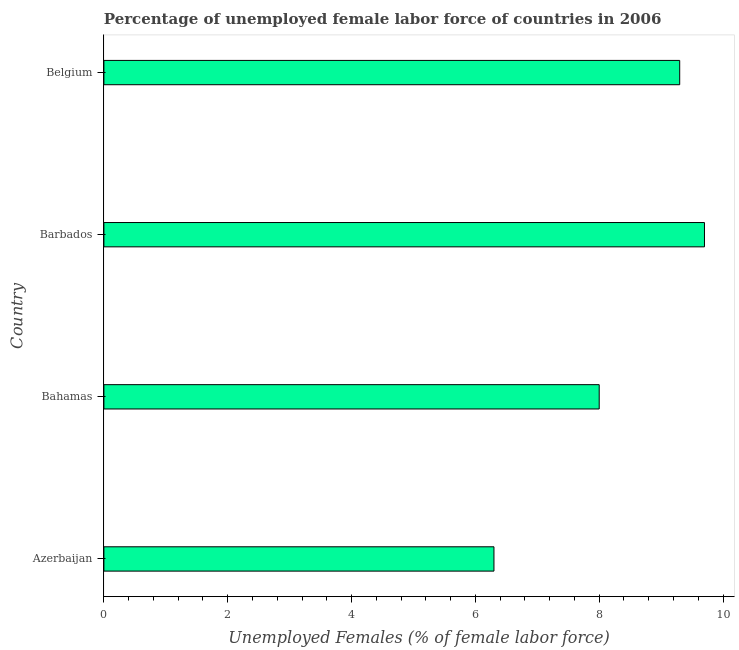Does the graph contain any zero values?
Your answer should be very brief. No. What is the title of the graph?
Keep it short and to the point. Percentage of unemployed female labor force of countries in 2006. What is the label or title of the X-axis?
Keep it short and to the point. Unemployed Females (% of female labor force). What is the label or title of the Y-axis?
Make the answer very short. Country. Across all countries, what is the maximum total unemployed female labour force?
Give a very brief answer. 9.7. Across all countries, what is the minimum total unemployed female labour force?
Make the answer very short. 6.3. In which country was the total unemployed female labour force maximum?
Your answer should be compact. Barbados. In which country was the total unemployed female labour force minimum?
Offer a terse response. Azerbaijan. What is the sum of the total unemployed female labour force?
Keep it short and to the point. 33.3. What is the difference between the total unemployed female labour force in Bahamas and Barbados?
Make the answer very short. -1.7. What is the average total unemployed female labour force per country?
Give a very brief answer. 8.32. What is the median total unemployed female labour force?
Give a very brief answer. 8.65. What is the ratio of the total unemployed female labour force in Azerbaijan to that in Bahamas?
Offer a very short reply. 0.79. What is the difference between the highest and the second highest total unemployed female labour force?
Make the answer very short. 0.4. Is the sum of the total unemployed female labour force in Azerbaijan and Barbados greater than the maximum total unemployed female labour force across all countries?
Provide a succinct answer. Yes. Are all the bars in the graph horizontal?
Provide a short and direct response. Yes. What is the Unemployed Females (% of female labor force) in Azerbaijan?
Give a very brief answer. 6.3. What is the Unemployed Females (% of female labor force) of Barbados?
Provide a succinct answer. 9.7. What is the Unemployed Females (% of female labor force) of Belgium?
Your response must be concise. 9.3. What is the difference between the Unemployed Females (% of female labor force) in Azerbaijan and Bahamas?
Give a very brief answer. -1.7. What is the difference between the Unemployed Females (% of female labor force) in Azerbaijan and Barbados?
Your answer should be very brief. -3.4. What is the difference between the Unemployed Females (% of female labor force) in Azerbaijan and Belgium?
Your response must be concise. -3. What is the difference between the Unemployed Females (% of female labor force) in Barbados and Belgium?
Your response must be concise. 0.4. What is the ratio of the Unemployed Females (% of female labor force) in Azerbaijan to that in Bahamas?
Offer a terse response. 0.79. What is the ratio of the Unemployed Females (% of female labor force) in Azerbaijan to that in Barbados?
Ensure brevity in your answer.  0.65. What is the ratio of the Unemployed Females (% of female labor force) in Azerbaijan to that in Belgium?
Offer a very short reply. 0.68. What is the ratio of the Unemployed Females (% of female labor force) in Bahamas to that in Barbados?
Make the answer very short. 0.82. What is the ratio of the Unemployed Females (% of female labor force) in Bahamas to that in Belgium?
Your response must be concise. 0.86. What is the ratio of the Unemployed Females (% of female labor force) in Barbados to that in Belgium?
Offer a very short reply. 1.04. 